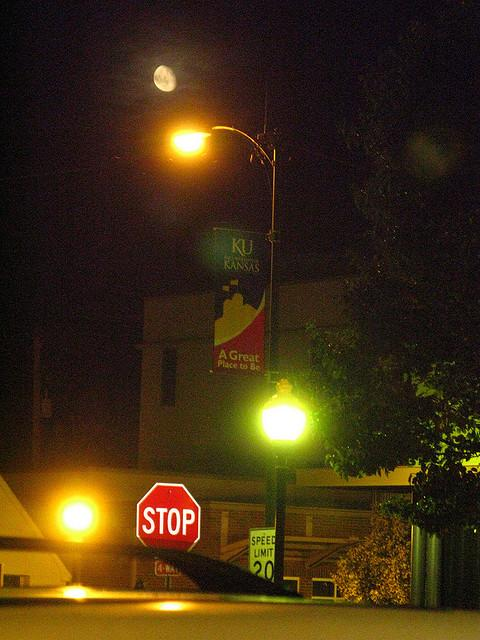How many lights are shining bright on the side of the campus street? Please explain your reasoning. three. There are 3. 